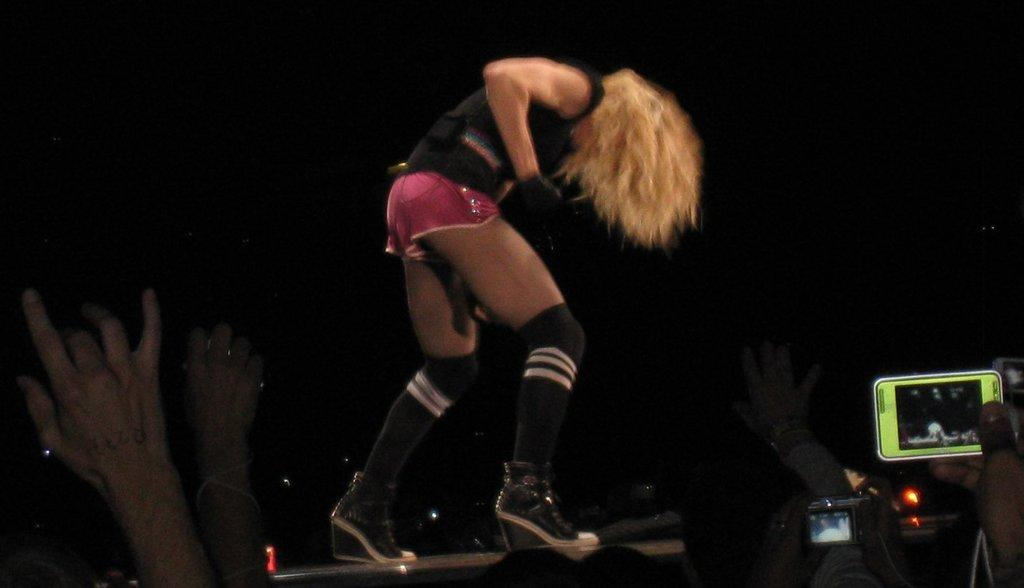What body parts are visible in the image? There are people's hands in the image. What is the person wearing in the image? There is a person wearing clothes in the image. What electronic device is located in the bottom right of the image? There is a camera in the bottom right of the image. What other electronic device is located in the bottom right of the image? There is a mobile in the bottom right of the image. What type of ornament is hanging from the ceiling in the image? There is no ornament hanging from the ceiling in the image. What kind of ship can be seen sailing in the background of the image? There is no ship visible in the image; it only features people's hands, a person wearing clothes, and electronic devices in the bottom right corner. 